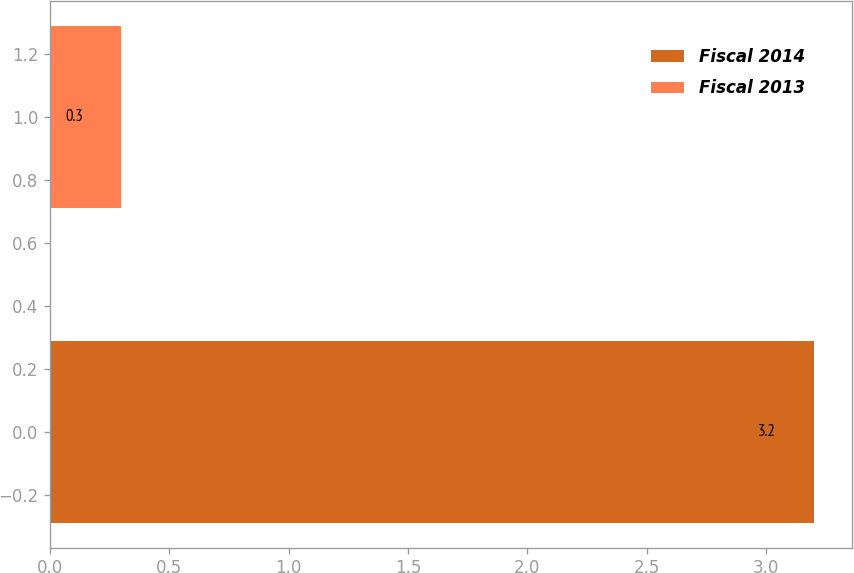<chart> <loc_0><loc_0><loc_500><loc_500><bar_chart><fcel>Fiscal 2014<fcel>Fiscal 2013<nl><fcel>3.2<fcel>0.3<nl></chart> 